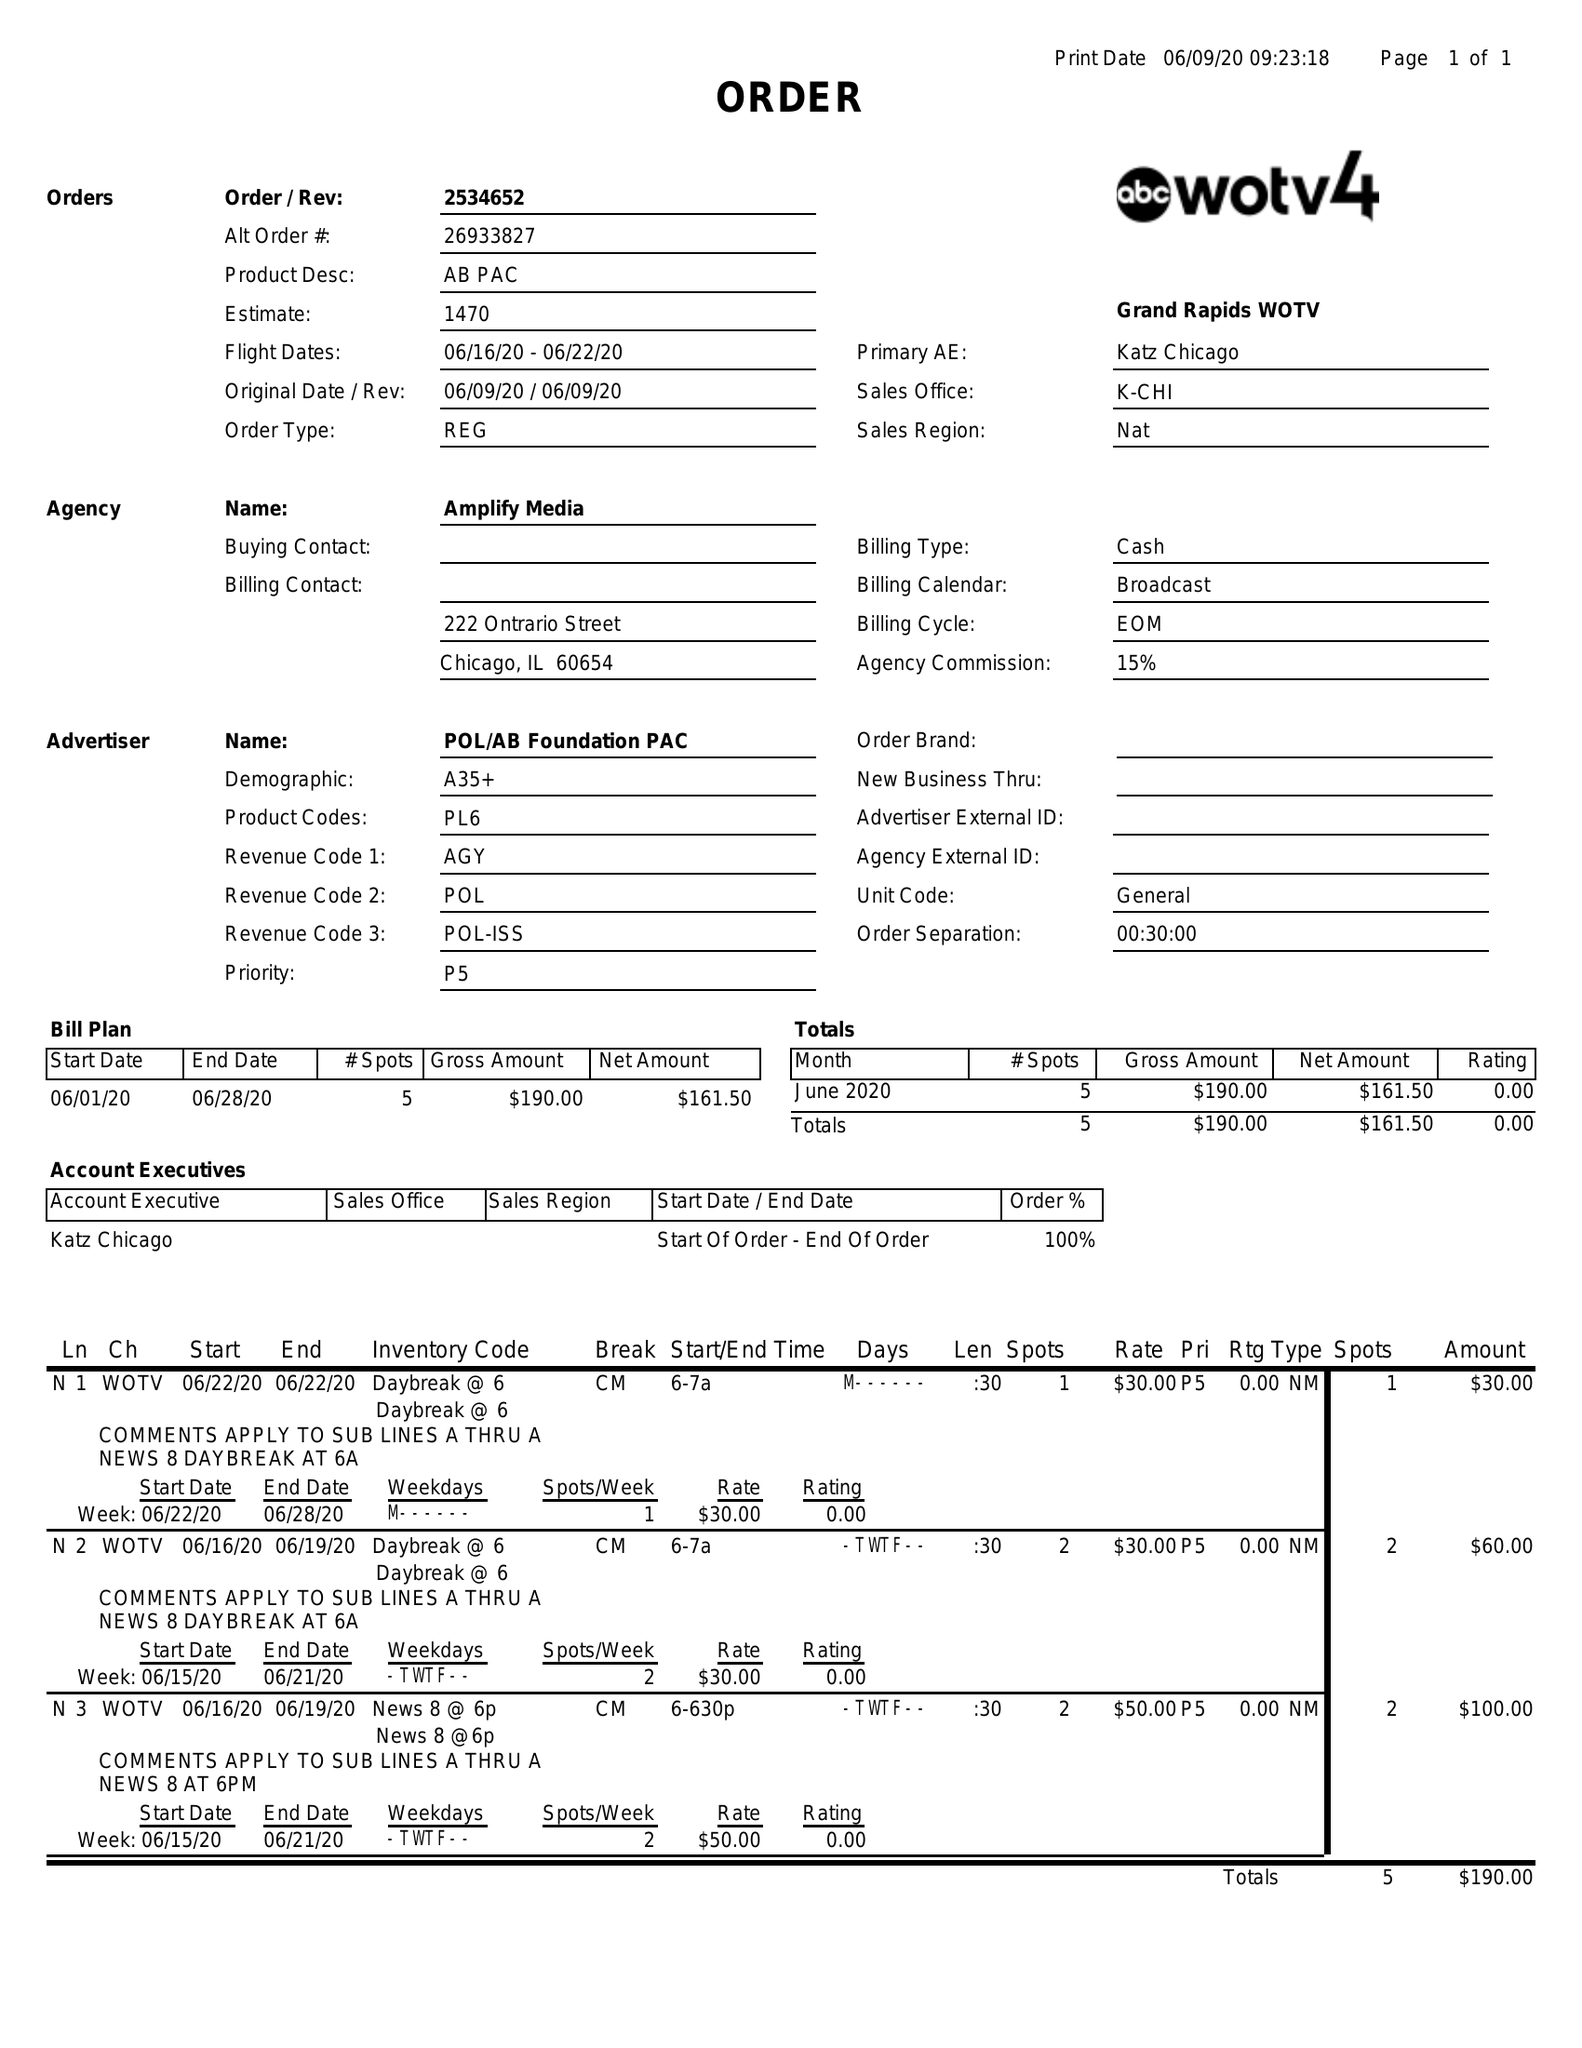What is the value for the flight_to?
Answer the question using a single word or phrase. 06/22/20 